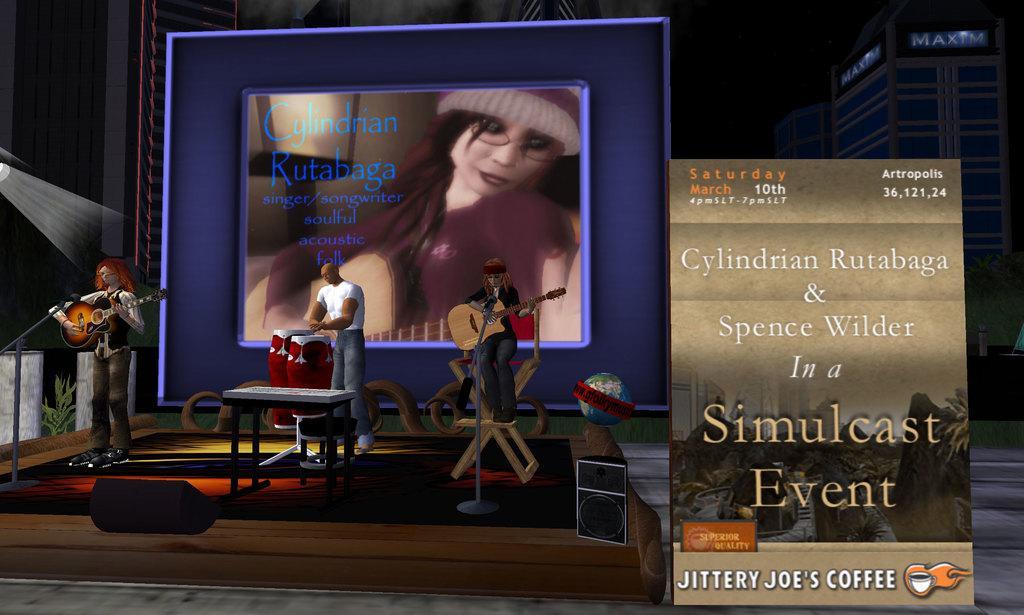How would you summarize this image in a sentence or two? In the picture we can see the animated image of three people are playing a musical instrument and behind them, we can see the screen and beside it, we can see the banner and behind it we can see the building. 